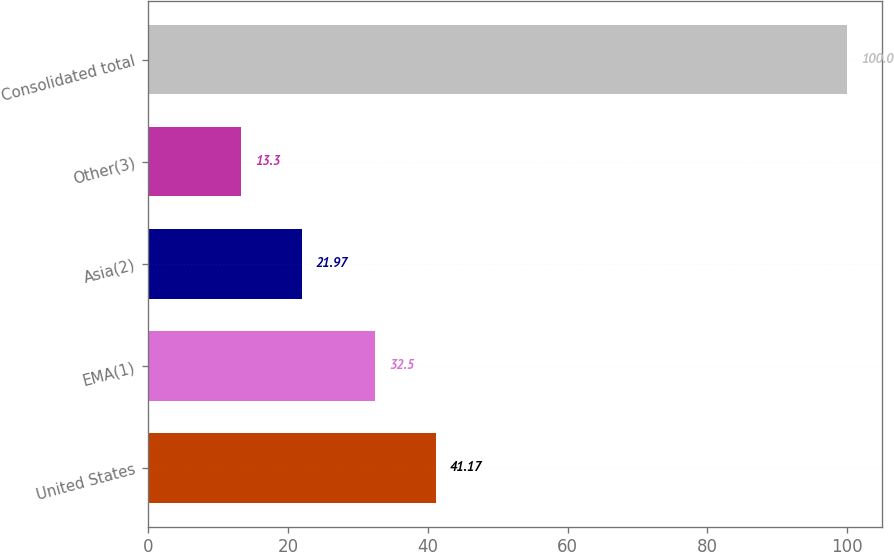Convert chart to OTSL. <chart><loc_0><loc_0><loc_500><loc_500><bar_chart><fcel>United States<fcel>EMA(1)<fcel>Asia(2)<fcel>Other(3)<fcel>Consolidated total<nl><fcel>41.17<fcel>32.5<fcel>21.97<fcel>13.3<fcel>100<nl></chart> 